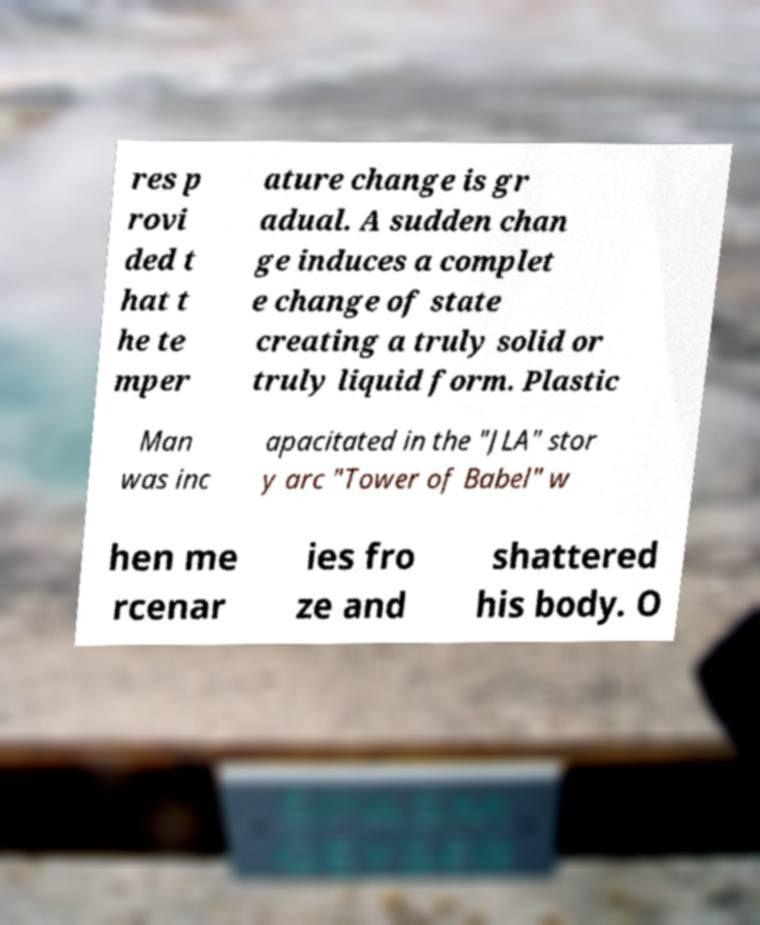What messages or text are displayed in this image? I need them in a readable, typed format. res p rovi ded t hat t he te mper ature change is gr adual. A sudden chan ge induces a complet e change of state creating a truly solid or truly liquid form. Plastic Man was inc apacitated in the "JLA" stor y arc "Tower of Babel" w hen me rcenar ies fro ze and shattered his body. O 